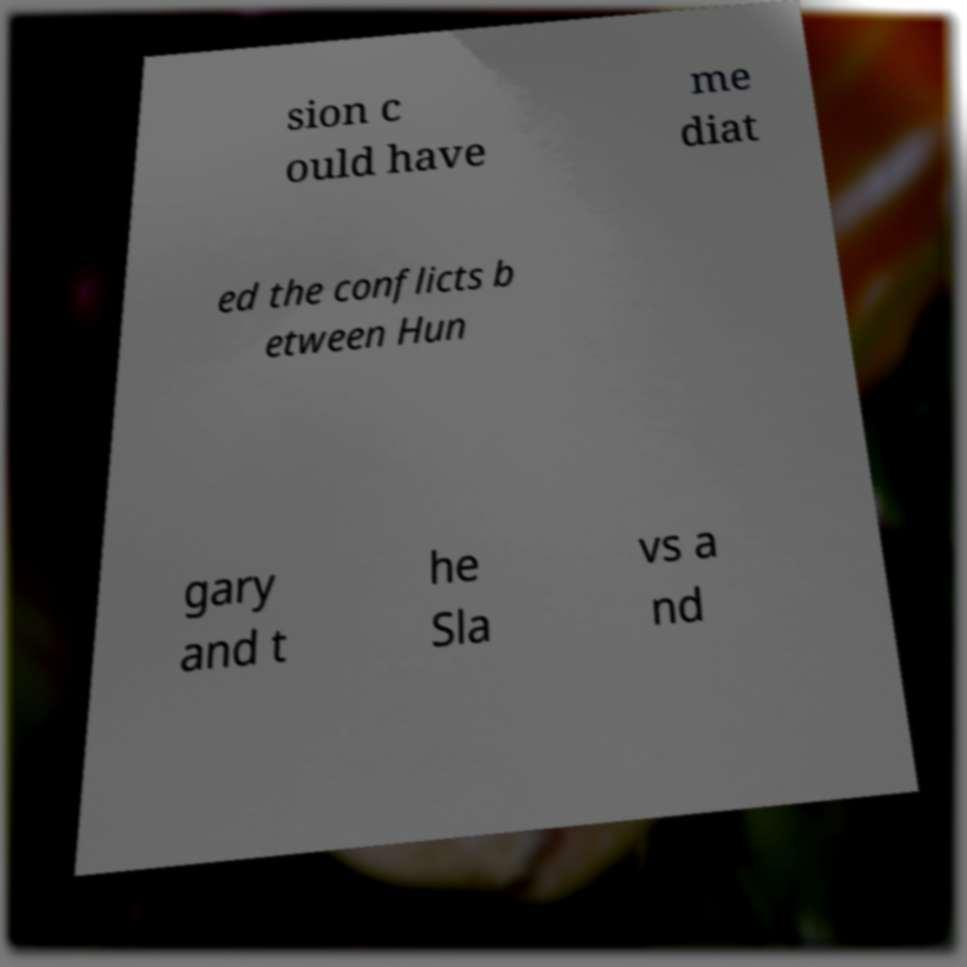What messages or text are displayed in this image? I need them in a readable, typed format. sion c ould have me diat ed the conflicts b etween Hun gary and t he Sla vs a nd 